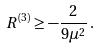Convert formula to latex. <formula><loc_0><loc_0><loc_500><loc_500>R ^ { ( 3 ) } \geq - \frac { 2 } { 9 \mu ^ { 2 } } \, .</formula> 